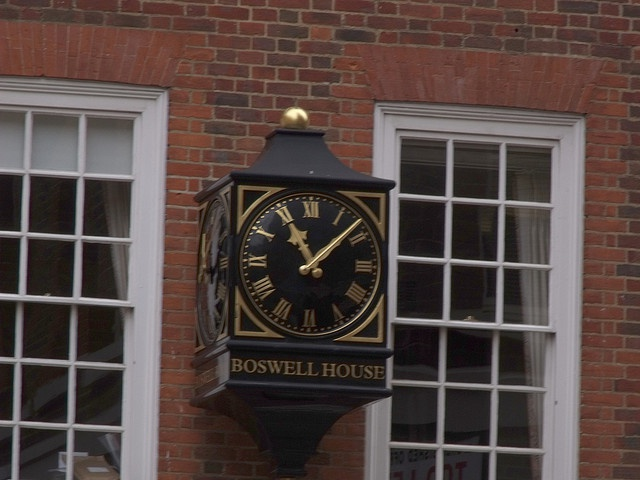Describe the objects in this image and their specific colors. I can see a clock in black and gray tones in this image. 